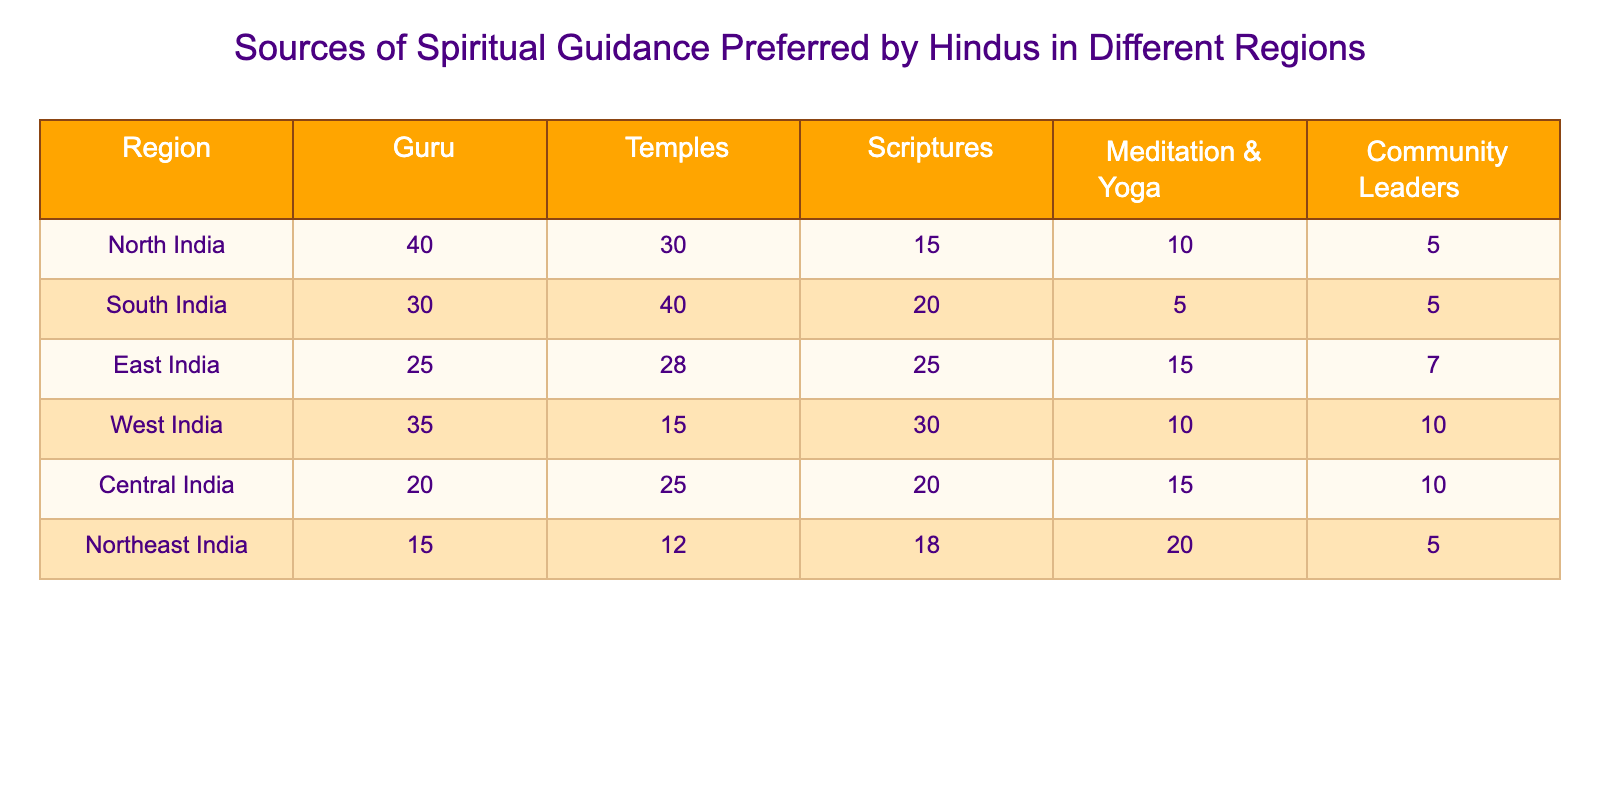What is the highest preferred source of spiritual guidance in North India? The table shows the values for each source of spiritual guidance in North India. The highest value is 40, which corresponds to the "Guru" category.
Answer: Guru In which region are Temples the most preferred source of spiritual guidance? Looking at the data for each region under the "Temples" column, South India has the highest count of 40 for this source of guidance.
Answer: South India What is the total number of preferences for Scriptures across all regions? To find the total number of preferences for Scriptures, we sum the values from the Scriptures column: 15 (North) + 20 (South) + 25 (East) + 30 (West) + 20 (Central) + 18 (Northeast) = 138.
Answer: 138 Is the preference for Meditation & Yoga highest in the Northeast India region? Comparing the value for Meditation & Yoga in the Northeast India region, which is 20, to the other regions: North India (10), South India (5), East India (15), West India (10), and Central India (15), we see that 20 is indeed the highest.
Answer: Yes What is the difference between the number of preferences for Community Leaders in North India and South India? The table shows 5 preferences for Community Leaders in North India and 5 preferences in South India. The difference is 5 - 5 = 0.
Answer: 0 Which source of spiritual guidance has the least preference in Central India? In Central India, we examine the values: Guru (20), Temples (25), Scriptures (20), Meditation & Yoga (15), and Community Leaders (10). The least preference here is 10 for Community Leaders.
Answer: Community Leaders What is the average number of preferences for Guru across all regions? We add the preferences for Guru: 40 (North) + 30 (South) + 25 (East) + 35 (West) + 20 (Central) + 15 (Northeast) = 165. There are 6 regions, so the average is 165 / 6 = 27.5.
Answer: 27.5 Is it true that West India has more preferences for Scriptures than Northeast India? For West India, the value is 30, and for Northeast India, it is 18. Since 30 is greater than 18, the statement is true.
Answer: Yes 